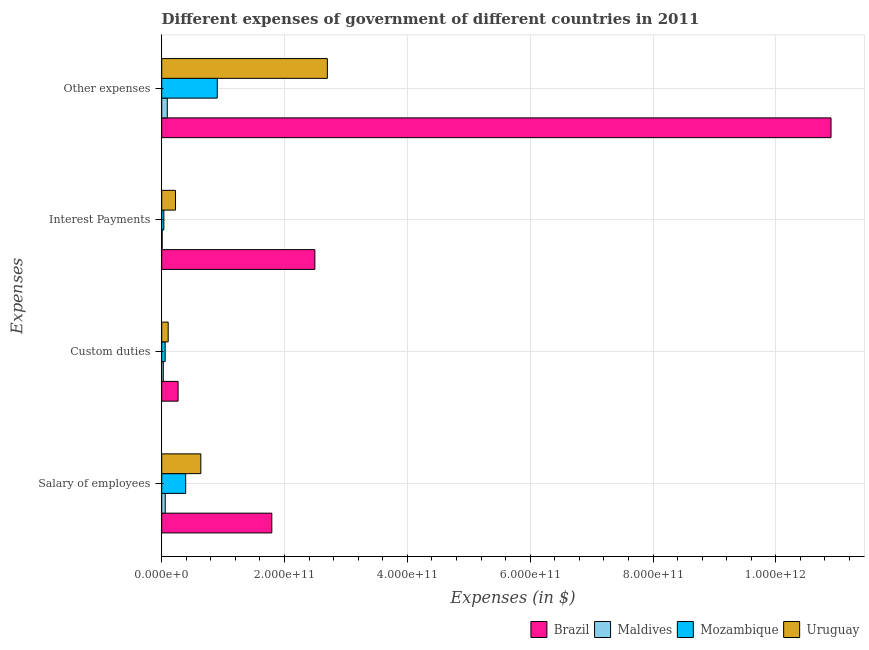How many different coloured bars are there?
Provide a succinct answer. 4. Are the number of bars per tick equal to the number of legend labels?
Your response must be concise. Yes. How many bars are there on the 3rd tick from the top?
Your answer should be very brief. 4. What is the label of the 2nd group of bars from the top?
Give a very brief answer. Interest Payments. What is the amount spent on interest payments in Brazil?
Provide a short and direct response. 2.49e+11. Across all countries, what is the maximum amount spent on other expenses?
Your response must be concise. 1.09e+12. Across all countries, what is the minimum amount spent on interest payments?
Make the answer very short. 7.26e+08. In which country was the amount spent on interest payments maximum?
Offer a very short reply. Brazil. In which country was the amount spent on custom duties minimum?
Keep it short and to the point. Maldives. What is the total amount spent on salary of employees in the graph?
Give a very brief answer. 2.88e+11. What is the difference between the amount spent on salary of employees in Brazil and that in Mozambique?
Ensure brevity in your answer.  1.40e+11. What is the difference between the amount spent on salary of employees in Mozambique and the amount spent on interest payments in Brazil?
Give a very brief answer. -2.10e+11. What is the average amount spent on salary of employees per country?
Ensure brevity in your answer.  7.19e+1. What is the difference between the amount spent on custom duties and amount spent on other expenses in Brazil?
Provide a short and direct response. -1.06e+12. In how many countries, is the amount spent on custom duties greater than 440000000000 $?
Your answer should be compact. 0. What is the ratio of the amount spent on custom duties in Brazil to that in Mozambique?
Ensure brevity in your answer.  4.76. Is the difference between the amount spent on salary of employees in Brazil and Mozambique greater than the difference between the amount spent on interest payments in Brazil and Mozambique?
Provide a succinct answer. No. What is the difference between the highest and the second highest amount spent on salary of employees?
Your response must be concise. 1.16e+11. What is the difference between the highest and the lowest amount spent on custom duties?
Your response must be concise. 2.41e+1. In how many countries, is the amount spent on custom duties greater than the average amount spent on custom duties taken over all countries?
Make the answer very short. 1. Is the sum of the amount spent on other expenses in Maldives and Mozambique greater than the maximum amount spent on custom duties across all countries?
Your answer should be very brief. Yes. Is it the case that in every country, the sum of the amount spent on other expenses and amount spent on interest payments is greater than the sum of amount spent on custom duties and amount spent on salary of employees?
Your answer should be very brief. No. What does the 2nd bar from the top in Other expenses represents?
Your answer should be compact. Mozambique. What does the 3rd bar from the bottom in Salary of employees represents?
Your answer should be compact. Mozambique. How many bars are there?
Your response must be concise. 16. Are all the bars in the graph horizontal?
Your answer should be compact. Yes. What is the difference between two consecutive major ticks on the X-axis?
Keep it short and to the point. 2.00e+11. Does the graph contain any zero values?
Your answer should be compact. No. Does the graph contain grids?
Your answer should be compact. Yes. Where does the legend appear in the graph?
Offer a very short reply. Bottom right. How are the legend labels stacked?
Offer a very short reply. Horizontal. What is the title of the graph?
Your answer should be compact. Different expenses of government of different countries in 2011. Does "Aruba" appear as one of the legend labels in the graph?
Ensure brevity in your answer.  No. What is the label or title of the X-axis?
Give a very brief answer. Expenses (in $). What is the label or title of the Y-axis?
Provide a short and direct response. Expenses. What is the Expenses (in $) of Brazil in Salary of employees?
Ensure brevity in your answer.  1.79e+11. What is the Expenses (in $) of Maldives in Salary of employees?
Keep it short and to the point. 5.73e+09. What is the Expenses (in $) in Mozambique in Salary of employees?
Keep it short and to the point. 3.90e+1. What is the Expenses (in $) in Uruguay in Salary of employees?
Offer a terse response. 6.37e+1. What is the Expenses (in $) in Brazil in Custom duties?
Offer a very short reply. 2.67e+1. What is the Expenses (in $) in Maldives in Custom duties?
Give a very brief answer. 2.59e+09. What is the Expenses (in $) of Mozambique in Custom duties?
Give a very brief answer. 5.61e+09. What is the Expenses (in $) of Uruguay in Custom duties?
Keep it short and to the point. 1.05e+1. What is the Expenses (in $) of Brazil in Interest Payments?
Keep it short and to the point. 2.49e+11. What is the Expenses (in $) in Maldives in Interest Payments?
Offer a very short reply. 7.26e+08. What is the Expenses (in $) of Mozambique in Interest Payments?
Provide a short and direct response. 3.50e+09. What is the Expenses (in $) of Uruguay in Interest Payments?
Your answer should be compact. 2.25e+1. What is the Expenses (in $) in Brazil in Other expenses?
Offer a very short reply. 1.09e+12. What is the Expenses (in $) in Maldives in Other expenses?
Provide a succinct answer. 9.08e+09. What is the Expenses (in $) in Mozambique in Other expenses?
Offer a terse response. 9.05e+1. What is the Expenses (in $) of Uruguay in Other expenses?
Ensure brevity in your answer.  2.70e+11. Across all Expenses, what is the maximum Expenses (in $) of Brazil?
Make the answer very short. 1.09e+12. Across all Expenses, what is the maximum Expenses (in $) in Maldives?
Make the answer very short. 9.08e+09. Across all Expenses, what is the maximum Expenses (in $) of Mozambique?
Ensure brevity in your answer.  9.05e+1. Across all Expenses, what is the maximum Expenses (in $) in Uruguay?
Provide a short and direct response. 2.70e+11. Across all Expenses, what is the minimum Expenses (in $) in Brazil?
Ensure brevity in your answer.  2.67e+1. Across all Expenses, what is the minimum Expenses (in $) in Maldives?
Make the answer very short. 7.26e+08. Across all Expenses, what is the minimum Expenses (in $) in Mozambique?
Offer a terse response. 3.50e+09. Across all Expenses, what is the minimum Expenses (in $) in Uruguay?
Provide a succinct answer. 1.05e+1. What is the total Expenses (in $) of Brazil in the graph?
Provide a short and direct response. 1.55e+12. What is the total Expenses (in $) of Maldives in the graph?
Your answer should be very brief. 1.81e+1. What is the total Expenses (in $) in Mozambique in the graph?
Provide a succinct answer. 1.39e+11. What is the total Expenses (in $) of Uruguay in the graph?
Provide a short and direct response. 3.66e+11. What is the difference between the Expenses (in $) of Brazil in Salary of employees and that in Custom duties?
Your answer should be compact. 1.53e+11. What is the difference between the Expenses (in $) in Maldives in Salary of employees and that in Custom duties?
Provide a short and direct response. 3.14e+09. What is the difference between the Expenses (in $) in Mozambique in Salary of employees and that in Custom duties?
Give a very brief answer. 3.34e+1. What is the difference between the Expenses (in $) of Uruguay in Salary of employees and that in Custom duties?
Offer a very short reply. 5.32e+1. What is the difference between the Expenses (in $) in Brazil in Salary of employees and that in Interest Payments?
Offer a terse response. -7.01e+1. What is the difference between the Expenses (in $) in Maldives in Salary of employees and that in Interest Payments?
Offer a terse response. 5.00e+09. What is the difference between the Expenses (in $) of Mozambique in Salary of employees and that in Interest Payments?
Ensure brevity in your answer.  3.55e+1. What is the difference between the Expenses (in $) of Uruguay in Salary of employees and that in Interest Payments?
Give a very brief answer. 4.12e+1. What is the difference between the Expenses (in $) in Brazil in Salary of employees and that in Other expenses?
Your response must be concise. -9.11e+11. What is the difference between the Expenses (in $) of Maldives in Salary of employees and that in Other expenses?
Provide a short and direct response. -3.35e+09. What is the difference between the Expenses (in $) in Mozambique in Salary of employees and that in Other expenses?
Provide a succinct answer. -5.15e+1. What is the difference between the Expenses (in $) in Uruguay in Salary of employees and that in Other expenses?
Ensure brevity in your answer.  -2.06e+11. What is the difference between the Expenses (in $) in Brazil in Custom duties and that in Interest Payments?
Make the answer very short. -2.23e+11. What is the difference between the Expenses (in $) of Maldives in Custom duties and that in Interest Payments?
Make the answer very short. 1.86e+09. What is the difference between the Expenses (in $) of Mozambique in Custom duties and that in Interest Payments?
Ensure brevity in your answer.  2.11e+09. What is the difference between the Expenses (in $) of Uruguay in Custom duties and that in Interest Payments?
Provide a succinct answer. -1.19e+1. What is the difference between the Expenses (in $) of Brazil in Custom duties and that in Other expenses?
Ensure brevity in your answer.  -1.06e+12. What is the difference between the Expenses (in $) of Maldives in Custom duties and that in Other expenses?
Your answer should be compact. -6.49e+09. What is the difference between the Expenses (in $) of Mozambique in Custom duties and that in Other expenses?
Offer a very short reply. -8.49e+1. What is the difference between the Expenses (in $) of Uruguay in Custom duties and that in Other expenses?
Your answer should be compact. -2.59e+11. What is the difference between the Expenses (in $) of Brazil in Interest Payments and that in Other expenses?
Offer a very short reply. -8.40e+11. What is the difference between the Expenses (in $) in Maldives in Interest Payments and that in Other expenses?
Give a very brief answer. -8.35e+09. What is the difference between the Expenses (in $) in Mozambique in Interest Payments and that in Other expenses?
Offer a very short reply. -8.70e+1. What is the difference between the Expenses (in $) in Uruguay in Interest Payments and that in Other expenses?
Give a very brief answer. -2.47e+11. What is the difference between the Expenses (in $) in Brazil in Salary of employees and the Expenses (in $) in Maldives in Custom duties?
Your answer should be compact. 1.77e+11. What is the difference between the Expenses (in $) in Brazil in Salary of employees and the Expenses (in $) in Mozambique in Custom duties?
Your answer should be very brief. 1.74e+11. What is the difference between the Expenses (in $) of Brazil in Salary of employees and the Expenses (in $) of Uruguay in Custom duties?
Your answer should be very brief. 1.69e+11. What is the difference between the Expenses (in $) of Maldives in Salary of employees and the Expenses (in $) of Mozambique in Custom duties?
Give a very brief answer. 1.16e+08. What is the difference between the Expenses (in $) in Maldives in Salary of employees and the Expenses (in $) in Uruguay in Custom duties?
Offer a terse response. -4.82e+09. What is the difference between the Expenses (in $) in Mozambique in Salary of employees and the Expenses (in $) in Uruguay in Custom duties?
Provide a succinct answer. 2.85e+1. What is the difference between the Expenses (in $) in Brazil in Salary of employees and the Expenses (in $) in Maldives in Interest Payments?
Provide a short and direct response. 1.79e+11. What is the difference between the Expenses (in $) of Brazil in Salary of employees and the Expenses (in $) of Mozambique in Interest Payments?
Provide a succinct answer. 1.76e+11. What is the difference between the Expenses (in $) of Brazil in Salary of employees and the Expenses (in $) of Uruguay in Interest Payments?
Keep it short and to the point. 1.57e+11. What is the difference between the Expenses (in $) of Maldives in Salary of employees and the Expenses (in $) of Mozambique in Interest Payments?
Make the answer very short. 2.22e+09. What is the difference between the Expenses (in $) of Maldives in Salary of employees and the Expenses (in $) of Uruguay in Interest Payments?
Your answer should be compact. -1.68e+1. What is the difference between the Expenses (in $) of Mozambique in Salary of employees and the Expenses (in $) of Uruguay in Interest Payments?
Keep it short and to the point. 1.66e+1. What is the difference between the Expenses (in $) of Brazil in Salary of employees and the Expenses (in $) of Maldives in Other expenses?
Your answer should be compact. 1.70e+11. What is the difference between the Expenses (in $) of Brazil in Salary of employees and the Expenses (in $) of Mozambique in Other expenses?
Keep it short and to the point. 8.88e+1. What is the difference between the Expenses (in $) of Brazil in Salary of employees and the Expenses (in $) of Uruguay in Other expenses?
Your response must be concise. -9.05e+1. What is the difference between the Expenses (in $) in Maldives in Salary of employees and the Expenses (in $) in Mozambique in Other expenses?
Offer a terse response. -8.48e+1. What is the difference between the Expenses (in $) in Maldives in Salary of employees and the Expenses (in $) in Uruguay in Other expenses?
Provide a succinct answer. -2.64e+11. What is the difference between the Expenses (in $) in Mozambique in Salary of employees and the Expenses (in $) in Uruguay in Other expenses?
Provide a short and direct response. -2.31e+11. What is the difference between the Expenses (in $) of Brazil in Custom duties and the Expenses (in $) of Maldives in Interest Payments?
Provide a short and direct response. 2.60e+1. What is the difference between the Expenses (in $) of Brazil in Custom duties and the Expenses (in $) of Mozambique in Interest Payments?
Make the answer very short. 2.32e+1. What is the difference between the Expenses (in $) of Brazil in Custom duties and the Expenses (in $) of Uruguay in Interest Payments?
Provide a succinct answer. 4.20e+09. What is the difference between the Expenses (in $) in Maldives in Custom duties and the Expenses (in $) in Mozambique in Interest Payments?
Your answer should be very brief. -9.15e+08. What is the difference between the Expenses (in $) of Maldives in Custom duties and the Expenses (in $) of Uruguay in Interest Payments?
Offer a very short reply. -1.99e+1. What is the difference between the Expenses (in $) of Mozambique in Custom duties and the Expenses (in $) of Uruguay in Interest Payments?
Your answer should be compact. -1.69e+1. What is the difference between the Expenses (in $) of Brazil in Custom duties and the Expenses (in $) of Maldives in Other expenses?
Keep it short and to the point. 1.76e+1. What is the difference between the Expenses (in $) in Brazil in Custom duties and the Expenses (in $) in Mozambique in Other expenses?
Your answer should be very brief. -6.38e+1. What is the difference between the Expenses (in $) in Brazil in Custom duties and the Expenses (in $) in Uruguay in Other expenses?
Provide a short and direct response. -2.43e+11. What is the difference between the Expenses (in $) of Maldives in Custom duties and the Expenses (in $) of Mozambique in Other expenses?
Provide a short and direct response. -8.79e+1. What is the difference between the Expenses (in $) in Maldives in Custom duties and the Expenses (in $) in Uruguay in Other expenses?
Provide a succinct answer. -2.67e+11. What is the difference between the Expenses (in $) of Mozambique in Custom duties and the Expenses (in $) of Uruguay in Other expenses?
Provide a succinct answer. -2.64e+11. What is the difference between the Expenses (in $) of Brazil in Interest Payments and the Expenses (in $) of Maldives in Other expenses?
Ensure brevity in your answer.  2.40e+11. What is the difference between the Expenses (in $) of Brazil in Interest Payments and the Expenses (in $) of Mozambique in Other expenses?
Your response must be concise. 1.59e+11. What is the difference between the Expenses (in $) in Brazil in Interest Payments and the Expenses (in $) in Uruguay in Other expenses?
Your response must be concise. -2.03e+1. What is the difference between the Expenses (in $) in Maldives in Interest Payments and the Expenses (in $) in Mozambique in Other expenses?
Give a very brief answer. -8.98e+1. What is the difference between the Expenses (in $) in Maldives in Interest Payments and the Expenses (in $) in Uruguay in Other expenses?
Your answer should be very brief. -2.69e+11. What is the difference between the Expenses (in $) in Mozambique in Interest Payments and the Expenses (in $) in Uruguay in Other expenses?
Your response must be concise. -2.66e+11. What is the average Expenses (in $) of Brazil per Expenses?
Provide a short and direct response. 3.86e+11. What is the average Expenses (in $) in Maldives per Expenses?
Your answer should be very brief. 4.53e+09. What is the average Expenses (in $) of Mozambique per Expenses?
Keep it short and to the point. 3.47e+1. What is the average Expenses (in $) of Uruguay per Expenses?
Provide a succinct answer. 9.16e+1. What is the difference between the Expenses (in $) of Brazil and Expenses (in $) of Maldives in Salary of employees?
Make the answer very short. 1.74e+11. What is the difference between the Expenses (in $) of Brazil and Expenses (in $) of Mozambique in Salary of employees?
Make the answer very short. 1.40e+11. What is the difference between the Expenses (in $) of Brazil and Expenses (in $) of Uruguay in Salary of employees?
Your answer should be compact. 1.16e+11. What is the difference between the Expenses (in $) of Maldives and Expenses (in $) of Mozambique in Salary of employees?
Provide a succinct answer. -3.33e+1. What is the difference between the Expenses (in $) in Maldives and Expenses (in $) in Uruguay in Salary of employees?
Your response must be concise. -5.80e+1. What is the difference between the Expenses (in $) in Mozambique and Expenses (in $) in Uruguay in Salary of employees?
Your answer should be compact. -2.47e+1. What is the difference between the Expenses (in $) in Brazil and Expenses (in $) in Maldives in Custom duties?
Keep it short and to the point. 2.41e+1. What is the difference between the Expenses (in $) of Brazil and Expenses (in $) of Mozambique in Custom duties?
Keep it short and to the point. 2.11e+1. What is the difference between the Expenses (in $) of Brazil and Expenses (in $) of Uruguay in Custom duties?
Offer a terse response. 1.61e+1. What is the difference between the Expenses (in $) of Maldives and Expenses (in $) of Mozambique in Custom duties?
Make the answer very short. -3.02e+09. What is the difference between the Expenses (in $) of Maldives and Expenses (in $) of Uruguay in Custom duties?
Give a very brief answer. -7.96e+09. What is the difference between the Expenses (in $) in Mozambique and Expenses (in $) in Uruguay in Custom duties?
Your answer should be compact. -4.93e+09. What is the difference between the Expenses (in $) of Brazil and Expenses (in $) of Maldives in Interest Payments?
Offer a terse response. 2.49e+11. What is the difference between the Expenses (in $) in Brazil and Expenses (in $) in Mozambique in Interest Payments?
Offer a very short reply. 2.46e+11. What is the difference between the Expenses (in $) of Brazil and Expenses (in $) of Uruguay in Interest Payments?
Offer a very short reply. 2.27e+11. What is the difference between the Expenses (in $) in Maldives and Expenses (in $) in Mozambique in Interest Payments?
Your answer should be very brief. -2.78e+09. What is the difference between the Expenses (in $) in Maldives and Expenses (in $) in Uruguay in Interest Payments?
Provide a short and direct response. -2.18e+1. What is the difference between the Expenses (in $) in Mozambique and Expenses (in $) in Uruguay in Interest Payments?
Make the answer very short. -1.90e+1. What is the difference between the Expenses (in $) in Brazil and Expenses (in $) in Maldives in Other expenses?
Provide a succinct answer. 1.08e+12. What is the difference between the Expenses (in $) of Brazil and Expenses (in $) of Mozambique in Other expenses?
Your response must be concise. 9.99e+11. What is the difference between the Expenses (in $) of Brazil and Expenses (in $) of Uruguay in Other expenses?
Offer a very short reply. 8.20e+11. What is the difference between the Expenses (in $) in Maldives and Expenses (in $) in Mozambique in Other expenses?
Your answer should be compact. -8.14e+1. What is the difference between the Expenses (in $) in Maldives and Expenses (in $) in Uruguay in Other expenses?
Give a very brief answer. -2.61e+11. What is the difference between the Expenses (in $) of Mozambique and Expenses (in $) of Uruguay in Other expenses?
Your response must be concise. -1.79e+11. What is the ratio of the Expenses (in $) of Brazil in Salary of employees to that in Custom duties?
Your answer should be compact. 6.72. What is the ratio of the Expenses (in $) of Maldives in Salary of employees to that in Custom duties?
Make the answer very short. 2.21. What is the ratio of the Expenses (in $) of Mozambique in Salary of employees to that in Custom duties?
Offer a terse response. 6.96. What is the ratio of the Expenses (in $) in Uruguay in Salary of employees to that in Custom duties?
Offer a terse response. 6.04. What is the ratio of the Expenses (in $) in Brazil in Salary of employees to that in Interest Payments?
Give a very brief answer. 0.72. What is the ratio of the Expenses (in $) of Maldives in Salary of employees to that in Interest Payments?
Your answer should be very brief. 7.89. What is the ratio of the Expenses (in $) in Mozambique in Salary of employees to that in Interest Payments?
Provide a succinct answer. 11.15. What is the ratio of the Expenses (in $) in Uruguay in Salary of employees to that in Interest Payments?
Provide a succinct answer. 2.83. What is the ratio of the Expenses (in $) of Brazil in Salary of employees to that in Other expenses?
Your response must be concise. 0.16. What is the ratio of the Expenses (in $) of Maldives in Salary of employees to that in Other expenses?
Provide a short and direct response. 0.63. What is the ratio of the Expenses (in $) of Mozambique in Salary of employees to that in Other expenses?
Give a very brief answer. 0.43. What is the ratio of the Expenses (in $) of Uruguay in Salary of employees to that in Other expenses?
Offer a terse response. 0.24. What is the ratio of the Expenses (in $) in Brazil in Custom duties to that in Interest Payments?
Offer a very short reply. 0.11. What is the ratio of the Expenses (in $) in Maldives in Custom duties to that in Interest Payments?
Your response must be concise. 3.56. What is the ratio of the Expenses (in $) of Mozambique in Custom duties to that in Interest Payments?
Provide a short and direct response. 1.6. What is the ratio of the Expenses (in $) of Uruguay in Custom duties to that in Interest Payments?
Keep it short and to the point. 0.47. What is the ratio of the Expenses (in $) in Brazil in Custom duties to that in Other expenses?
Your answer should be compact. 0.02. What is the ratio of the Expenses (in $) in Maldives in Custom duties to that in Other expenses?
Your answer should be compact. 0.28. What is the ratio of the Expenses (in $) of Mozambique in Custom duties to that in Other expenses?
Offer a terse response. 0.06. What is the ratio of the Expenses (in $) in Uruguay in Custom duties to that in Other expenses?
Offer a very short reply. 0.04. What is the ratio of the Expenses (in $) of Brazil in Interest Payments to that in Other expenses?
Your response must be concise. 0.23. What is the ratio of the Expenses (in $) of Mozambique in Interest Payments to that in Other expenses?
Make the answer very short. 0.04. What is the ratio of the Expenses (in $) in Uruguay in Interest Payments to that in Other expenses?
Your response must be concise. 0.08. What is the difference between the highest and the second highest Expenses (in $) in Brazil?
Give a very brief answer. 8.40e+11. What is the difference between the highest and the second highest Expenses (in $) in Maldives?
Make the answer very short. 3.35e+09. What is the difference between the highest and the second highest Expenses (in $) of Mozambique?
Provide a short and direct response. 5.15e+1. What is the difference between the highest and the second highest Expenses (in $) of Uruguay?
Offer a terse response. 2.06e+11. What is the difference between the highest and the lowest Expenses (in $) in Brazil?
Your response must be concise. 1.06e+12. What is the difference between the highest and the lowest Expenses (in $) of Maldives?
Your answer should be very brief. 8.35e+09. What is the difference between the highest and the lowest Expenses (in $) in Mozambique?
Keep it short and to the point. 8.70e+1. What is the difference between the highest and the lowest Expenses (in $) of Uruguay?
Your answer should be compact. 2.59e+11. 